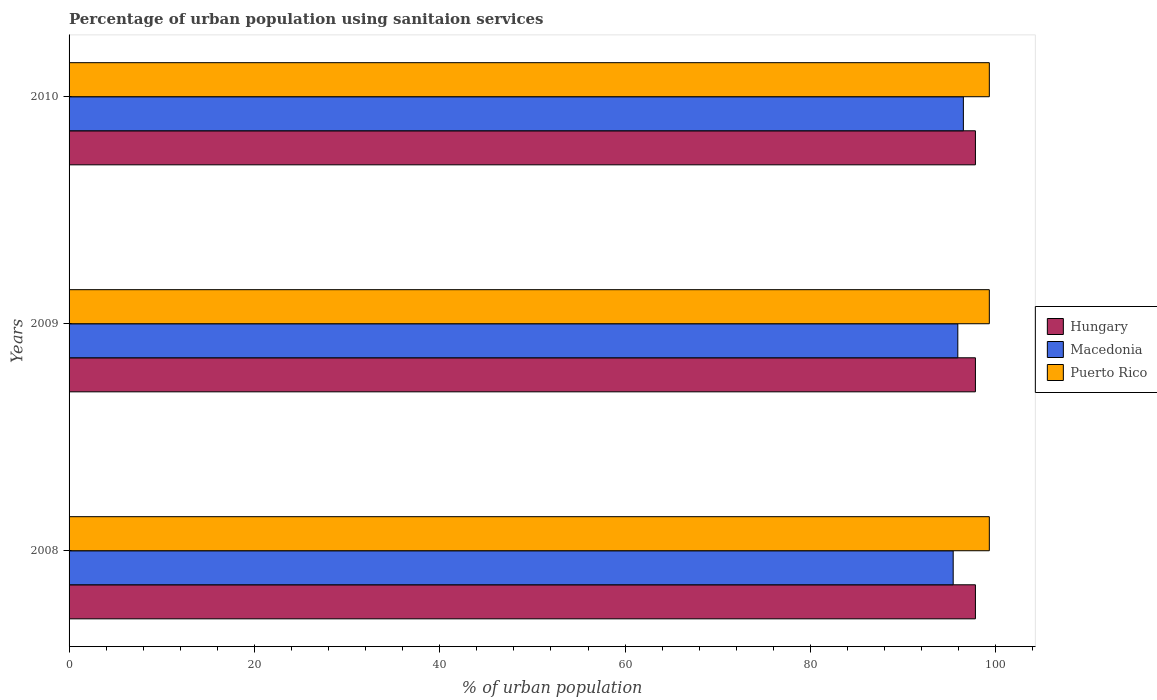Are the number of bars on each tick of the Y-axis equal?
Your answer should be compact. Yes. What is the label of the 1st group of bars from the top?
Ensure brevity in your answer.  2010. What is the percentage of urban population using sanitaion services in Puerto Rico in 2009?
Your response must be concise. 99.3. Across all years, what is the maximum percentage of urban population using sanitaion services in Macedonia?
Your answer should be very brief. 96.5. Across all years, what is the minimum percentage of urban population using sanitaion services in Puerto Rico?
Provide a succinct answer. 99.3. In which year was the percentage of urban population using sanitaion services in Puerto Rico maximum?
Ensure brevity in your answer.  2008. What is the total percentage of urban population using sanitaion services in Hungary in the graph?
Give a very brief answer. 293.4. What is the difference between the percentage of urban population using sanitaion services in Macedonia in 2008 and that in 2009?
Provide a short and direct response. -0.5. What is the difference between the percentage of urban population using sanitaion services in Macedonia in 2009 and the percentage of urban population using sanitaion services in Hungary in 2008?
Offer a terse response. -1.9. What is the average percentage of urban population using sanitaion services in Macedonia per year?
Make the answer very short. 95.93. In how many years, is the percentage of urban population using sanitaion services in Hungary greater than 60 %?
Provide a succinct answer. 3. Is the percentage of urban population using sanitaion services in Hungary in 2008 less than that in 2010?
Your answer should be compact. No. Is the difference between the percentage of urban population using sanitaion services in Hungary in 2008 and 2009 greater than the difference between the percentage of urban population using sanitaion services in Puerto Rico in 2008 and 2009?
Your answer should be very brief. No. What is the difference between the highest and the lowest percentage of urban population using sanitaion services in Macedonia?
Ensure brevity in your answer.  1.1. In how many years, is the percentage of urban population using sanitaion services in Puerto Rico greater than the average percentage of urban population using sanitaion services in Puerto Rico taken over all years?
Provide a succinct answer. 0. What does the 3rd bar from the top in 2009 represents?
Ensure brevity in your answer.  Hungary. What does the 2nd bar from the bottom in 2010 represents?
Ensure brevity in your answer.  Macedonia. Is it the case that in every year, the sum of the percentage of urban population using sanitaion services in Puerto Rico and percentage of urban population using sanitaion services in Macedonia is greater than the percentage of urban population using sanitaion services in Hungary?
Ensure brevity in your answer.  Yes. How many bars are there?
Your answer should be compact. 9. How many years are there in the graph?
Your answer should be very brief. 3. What is the difference between two consecutive major ticks on the X-axis?
Make the answer very short. 20. Does the graph contain any zero values?
Ensure brevity in your answer.  No. Does the graph contain grids?
Ensure brevity in your answer.  No. How are the legend labels stacked?
Your answer should be compact. Vertical. What is the title of the graph?
Make the answer very short. Percentage of urban population using sanitaion services. What is the label or title of the X-axis?
Offer a very short reply. % of urban population. What is the % of urban population in Hungary in 2008?
Your response must be concise. 97.8. What is the % of urban population in Macedonia in 2008?
Keep it short and to the point. 95.4. What is the % of urban population of Puerto Rico in 2008?
Ensure brevity in your answer.  99.3. What is the % of urban population of Hungary in 2009?
Provide a short and direct response. 97.8. What is the % of urban population of Macedonia in 2009?
Offer a very short reply. 95.9. What is the % of urban population in Puerto Rico in 2009?
Give a very brief answer. 99.3. What is the % of urban population of Hungary in 2010?
Your answer should be compact. 97.8. What is the % of urban population in Macedonia in 2010?
Make the answer very short. 96.5. What is the % of urban population in Puerto Rico in 2010?
Your answer should be compact. 99.3. Across all years, what is the maximum % of urban population of Hungary?
Provide a succinct answer. 97.8. Across all years, what is the maximum % of urban population of Macedonia?
Offer a very short reply. 96.5. Across all years, what is the maximum % of urban population of Puerto Rico?
Make the answer very short. 99.3. Across all years, what is the minimum % of urban population in Hungary?
Make the answer very short. 97.8. Across all years, what is the minimum % of urban population of Macedonia?
Your response must be concise. 95.4. Across all years, what is the minimum % of urban population of Puerto Rico?
Offer a terse response. 99.3. What is the total % of urban population in Hungary in the graph?
Offer a terse response. 293.4. What is the total % of urban population of Macedonia in the graph?
Keep it short and to the point. 287.8. What is the total % of urban population in Puerto Rico in the graph?
Give a very brief answer. 297.9. What is the difference between the % of urban population in Hungary in 2008 and that in 2009?
Ensure brevity in your answer.  0. What is the difference between the % of urban population of Hungary in 2008 and that in 2010?
Your answer should be compact. 0. What is the difference between the % of urban population of Puerto Rico in 2008 and that in 2010?
Provide a succinct answer. 0. What is the difference between the % of urban population of Hungary in 2009 and that in 2010?
Ensure brevity in your answer.  0. What is the difference between the % of urban population in Macedonia in 2009 and that in 2010?
Make the answer very short. -0.6. What is the difference between the % of urban population in Hungary in 2008 and the % of urban population in Puerto Rico in 2009?
Your response must be concise. -1.5. What is the difference between the % of urban population of Macedonia in 2008 and the % of urban population of Puerto Rico in 2009?
Keep it short and to the point. -3.9. What is the difference between the % of urban population in Hungary in 2008 and the % of urban population in Puerto Rico in 2010?
Offer a very short reply. -1.5. What is the difference between the % of urban population in Macedonia in 2008 and the % of urban population in Puerto Rico in 2010?
Provide a succinct answer. -3.9. What is the difference between the % of urban population of Hungary in 2009 and the % of urban population of Macedonia in 2010?
Your answer should be very brief. 1.3. What is the difference between the % of urban population of Hungary in 2009 and the % of urban population of Puerto Rico in 2010?
Keep it short and to the point. -1.5. What is the difference between the % of urban population of Macedonia in 2009 and the % of urban population of Puerto Rico in 2010?
Offer a very short reply. -3.4. What is the average % of urban population of Hungary per year?
Make the answer very short. 97.8. What is the average % of urban population of Macedonia per year?
Provide a short and direct response. 95.93. What is the average % of urban population in Puerto Rico per year?
Keep it short and to the point. 99.3. In the year 2008, what is the difference between the % of urban population in Hungary and % of urban population in Macedonia?
Your response must be concise. 2.4. In the year 2008, what is the difference between the % of urban population in Hungary and % of urban population in Puerto Rico?
Your answer should be compact. -1.5. In the year 2009, what is the difference between the % of urban population in Hungary and % of urban population in Macedonia?
Your answer should be compact. 1.9. What is the ratio of the % of urban population in Puerto Rico in 2008 to that in 2010?
Your answer should be very brief. 1. What is the ratio of the % of urban population in Hungary in 2009 to that in 2010?
Ensure brevity in your answer.  1. What is the ratio of the % of urban population of Macedonia in 2009 to that in 2010?
Your answer should be compact. 0.99. What is the difference between the highest and the second highest % of urban population of Hungary?
Your response must be concise. 0. What is the difference between the highest and the second highest % of urban population of Macedonia?
Your answer should be very brief. 0.6. What is the difference between the highest and the second highest % of urban population in Puerto Rico?
Provide a succinct answer. 0. What is the difference between the highest and the lowest % of urban population in Macedonia?
Make the answer very short. 1.1. What is the difference between the highest and the lowest % of urban population in Puerto Rico?
Your response must be concise. 0. 